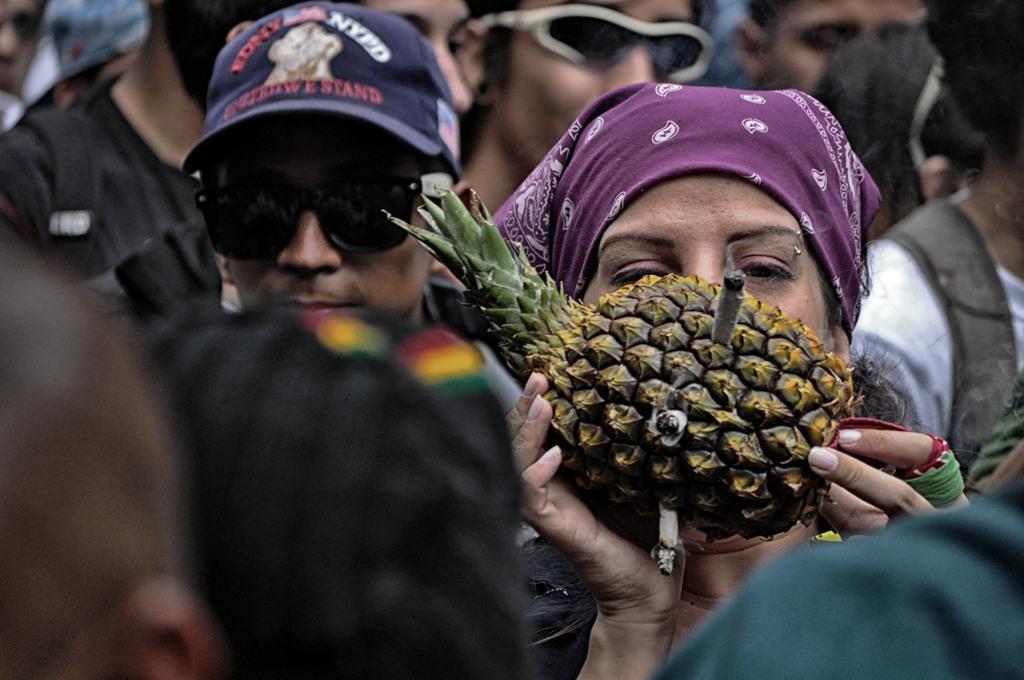Please provide a concise description of this image. In this image there is a lady holding pineapple in which cigarettes are plucked inside, behind her there are so many people standing. 